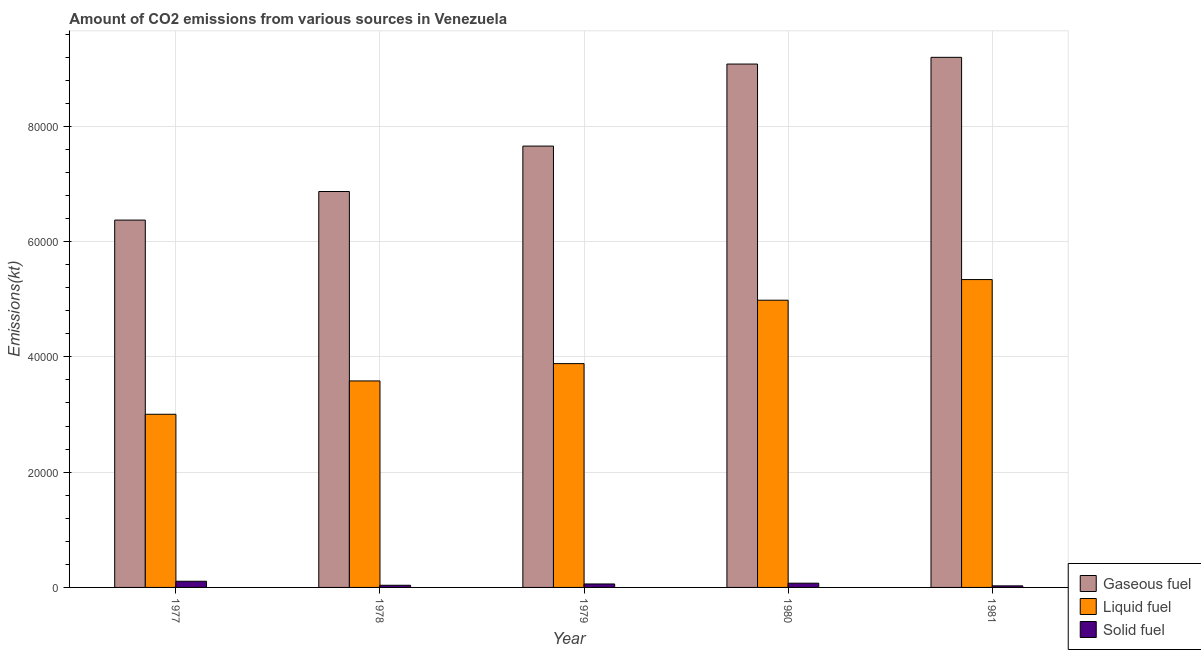Are the number of bars per tick equal to the number of legend labels?
Your answer should be very brief. Yes. How many bars are there on the 5th tick from the left?
Your answer should be very brief. 3. What is the label of the 4th group of bars from the left?
Give a very brief answer. 1980. In how many cases, is the number of bars for a given year not equal to the number of legend labels?
Your answer should be very brief. 0. What is the amount of co2 emissions from gaseous fuel in 1981?
Your answer should be very brief. 9.20e+04. Across all years, what is the maximum amount of co2 emissions from gaseous fuel?
Your answer should be compact. 9.20e+04. Across all years, what is the minimum amount of co2 emissions from solid fuel?
Keep it short and to the point. 271.36. In which year was the amount of co2 emissions from liquid fuel minimum?
Provide a succinct answer. 1977. What is the total amount of co2 emissions from liquid fuel in the graph?
Offer a very short reply. 2.08e+05. What is the difference between the amount of co2 emissions from liquid fuel in 1977 and that in 1979?
Offer a very short reply. -8789.8. What is the difference between the amount of co2 emissions from liquid fuel in 1978 and the amount of co2 emissions from solid fuel in 1981?
Offer a very short reply. -1.76e+04. What is the average amount of co2 emissions from solid fuel per year?
Your answer should be very brief. 610.19. What is the ratio of the amount of co2 emissions from solid fuel in 1980 to that in 1981?
Provide a short and direct response. 2.7. What is the difference between the highest and the second highest amount of co2 emissions from liquid fuel?
Your answer should be very brief. 3578.99. What is the difference between the highest and the lowest amount of co2 emissions from gaseous fuel?
Make the answer very short. 2.82e+04. In how many years, is the amount of co2 emissions from gaseous fuel greater than the average amount of co2 emissions from gaseous fuel taken over all years?
Your answer should be compact. 2. What does the 2nd bar from the left in 1979 represents?
Offer a terse response. Liquid fuel. What does the 2nd bar from the right in 1979 represents?
Your answer should be very brief. Liquid fuel. Is it the case that in every year, the sum of the amount of co2 emissions from gaseous fuel and amount of co2 emissions from liquid fuel is greater than the amount of co2 emissions from solid fuel?
Provide a short and direct response. Yes. What is the difference between two consecutive major ticks on the Y-axis?
Your answer should be very brief. 2.00e+04. Are the values on the major ticks of Y-axis written in scientific E-notation?
Keep it short and to the point. No. Does the graph contain any zero values?
Make the answer very short. No. Does the graph contain grids?
Keep it short and to the point. Yes. How many legend labels are there?
Offer a terse response. 3. How are the legend labels stacked?
Give a very brief answer. Vertical. What is the title of the graph?
Your answer should be compact. Amount of CO2 emissions from various sources in Venezuela. What is the label or title of the X-axis?
Your answer should be compact. Year. What is the label or title of the Y-axis?
Provide a short and direct response. Emissions(kt). What is the Emissions(kt) in Gaseous fuel in 1977?
Ensure brevity in your answer.  6.37e+04. What is the Emissions(kt) in Liquid fuel in 1977?
Provide a short and direct response. 3.00e+04. What is the Emissions(kt) of Solid fuel in 1977?
Your answer should be compact. 1070.76. What is the Emissions(kt) of Gaseous fuel in 1978?
Ensure brevity in your answer.  6.87e+04. What is the Emissions(kt) in Liquid fuel in 1978?
Keep it short and to the point. 3.58e+04. What is the Emissions(kt) of Solid fuel in 1978?
Provide a short and direct response. 374.03. What is the Emissions(kt) in Gaseous fuel in 1979?
Keep it short and to the point. 7.66e+04. What is the Emissions(kt) of Liquid fuel in 1979?
Offer a terse response. 3.88e+04. What is the Emissions(kt) in Solid fuel in 1979?
Ensure brevity in your answer.  601.39. What is the Emissions(kt) of Gaseous fuel in 1980?
Provide a short and direct response. 9.08e+04. What is the Emissions(kt) of Liquid fuel in 1980?
Offer a terse response. 4.98e+04. What is the Emissions(kt) in Solid fuel in 1980?
Make the answer very short. 733.4. What is the Emissions(kt) of Gaseous fuel in 1981?
Ensure brevity in your answer.  9.20e+04. What is the Emissions(kt) in Liquid fuel in 1981?
Provide a succinct answer. 5.34e+04. What is the Emissions(kt) in Solid fuel in 1981?
Give a very brief answer. 271.36. Across all years, what is the maximum Emissions(kt) of Gaseous fuel?
Provide a short and direct response. 9.20e+04. Across all years, what is the maximum Emissions(kt) of Liquid fuel?
Make the answer very short. 5.34e+04. Across all years, what is the maximum Emissions(kt) in Solid fuel?
Keep it short and to the point. 1070.76. Across all years, what is the minimum Emissions(kt) in Gaseous fuel?
Offer a terse response. 6.37e+04. Across all years, what is the minimum Emissions(kt) of Liquid fuel?
Your answer should be very brief. 3.00e+04. Across all years, what is the minimum Emissions(kt) in Solid fuel?
Provide a succinct answer. 271.36. What is the total Emissions(kt) in Gaseous fuel in the graph?
Keep it short and to the point. 3.92e+05. What is the total Emissions(kt) in Liquid fuel in the graph?
Your response must be concise. 2.08e+05. What is the total Emissions(kt) of Solid fuel in the graph?
Your answer should be compact. 3050.94. What is the difference between the Emissions(kt) of Gaseous fuel in 1977 and that in 1978?
Offer a very short reply. -4957.78. What is the difference between the Emissions(kt) in Liquid fuel in 1977 and that in 1978?
Offer a terse response. -5786.53. What is the difference between the Emissions(kt) of Solid fuel in 1977 and that in 1978?
Provide a short and direct response. 696.73. What is the difference between the Emissions(kt) in Gaseous fuel in 1977 and that in 1979?
Give a very brief answer. -1.28e+04. What is the difference between the Emissions(kt) in Liquid fuel in 1977 and that in 1979?
Ensure brevity in your answer.  -8789.8. What is the difference between the Emissions(kt) of Solid fuel in 1977 and that in 1979?
Your answer should be compact. 469.38. What is the difference between the Emissions(kt) in Gaseous fuel in 1977 and that in 1980?
Offer a terse response. -2.71e+04. What is the difference between the Emissions(kt) of Liquid fuel in 1977 and that in 1980?
Your response must be concise. -1.98e+04. What is the difference between the Emissions(kt) of Solid fuel in 1977 and that in 1980?
Your answer should be compact. 337.36. What is the difference between the Emissions(kt) in Gaseous fuel in 1977 and that in 1981?
Your response must be concise. -2.82e+04. What is the difference between the Emissions(kt) of Liquid fuel in 1977 and that in 1981?
Make the answer very short. -2.34e+04. What is the difference between the Emissions(kt) of Solid fuel in 1977 and that in 1981?
Provide a succinct answer. 799.41. What is the difference between the Emissions(kt) of Gaseous fuel in 1978 and that in 1979?
Give a very brief answer. -7880.38. What is the difference between the Emissions(kt) in Liquid fuel in 1978 and that in 1979?
Your answer should be compact. -3003.27. What is the difference between the Emissions(kt) of Solid fuel in 1978 and that in 1979?
Ensure brevity in your answer.  -227.35. What is the difference between the Emissions(kt) of Gaseous fuel in 1978 and that in 1980?
Offer a terse response. -2.21e+04. What is the difference between the Emissions(kt) of Liquid fuel in 1978 and that in 1980?
Ensure brevity in your answer.  -1.40e+04. What is the difference between the Emissions(kt) in Solid fuel in 1978 and that in 1980?
Keep it short and to the point. -359.37. What is the difference between the Emissions(kt) of Gaseous fuel in 1978 and that in 1981?
Make the answer very short. -2.33e+04. What is the difference between the Emissions(kt) in Liquid fuel in 1978 and that in 1981?
Give a very brief answer. -1.76e+04. What is the difference between the Emissions(kt) of Solid fuel in 1978 and that in 1981?
Give a very brief answer. 102.68. What is the difference between the Emissions(kt) of Gaseous fuel in 1979 and that in 1980?
Your response must be concise. -1.42e+04. What is the difference between the Emissions(kt) in Liquid fuel in 1979 and that in 1980?
Your response must be concise. -1.10e+04. What is the difference between the Emissions(kt) of Solid fuel in 1979 and that in 1980?
Your answer should be compact. -132.01. What is the difference between the Emissions(kt) in Gaseous fuel in 1979 and that in 1981?
Give a very brief answer. -1.54e+04. What is the difference between the Emissions(kt) of Liquid fuel in 1979 and that in 1981?
Provide a succinct answer. -1.46e+04. What is the difference between the Emissions(kt) in Solid fuel in 1979 and that in 1981?
Offer a terse response. 330.03. What is the difference between the Emissions(kt) of Gaseous fuel in 1980 and that in 1981?
Provide a short and direct response. -1166.11. What is the difference between the Emissions(kt) in Liquid fuel in 1980 and that in 1981?
Ensure brevity in your answer.  -3578.99. What is the difference between the Emissions(kt) of Solid fuel in 1980 and that in 1981?
Keep it short and to the point. 462.04. What is the difference between the Emissions(kt) in Gaseous fuel in 1977 and the Emissions(kt) in Liquid fuel in 1978?
Your answer should be compact. 2.79e+04. What is the difference between the Emissions(kt) of Gaseous fuel in 1977 and the Emissions(kt) of Solid fuel in 1978?
Offer a very short reply. 6.34e+04. What is the difference between the Emissions(kt) of Liquid fuel in 1977 and the Emissions(kt) of Solid fuel in 1978?
Give a very brief answer. 2.97e+04. What is the difference between the Emissions(kt) of Gaseous fuel in 1977 and the Emissions(kt) of Liquid fuel in 1979?
Provide a succinct answer. 2.49e+04. What is the difference between the Emissions(kt) of Gaseous fuel in 1977 and the Emissions(kt) of Solid fuel in 1979?
Offer a terse response. 6.31e+04. What is the difference between the Emissions(kt) of Liquid fuel in 1977 and the Emissions(kt) of Solid fuel in 1979?
Make the answer very short. 2.94e+04. What is the difference between the Emissions(kt) in Gaseous fuel in 1977 and the Emissions(kt) in Liquid fuel in 1980?
Your response must be concise. 1.39e+04. What is the difference between the Emissions(kt) of Gaseous fuel in 1977 and the Emissions(kt) of Solid fuel in 1980?
Offer a terse response. 6.30e+04. What is the difference between the Emissions(kt) in Liquid fuel in 1977 and the Emissions(kt) in Solid fuel in 1980?
Make the answer very short. 2.93e+04. What is the difference between the Emissions(kt) of Gaseous fuel in 1977 and the Emissions(kt) of Liquid fuel in 1981?
Provide a succinct answer. 1.03e+04. What is the difference between the Emissions(kt) in Gaseous fuel in 1977 and the Emissions(kt) in Solid fuel in 1981?
Provide a succinct answer. 6.35e+04. What is the difference between the Emissions(kt) in Liquid fuel in 1977 and the Emissions(kt) in Solid fuel in 1981?
Your answer should be compact. 2.98e+04. What is the difference between the Emissions(kt) of Gaseous fuel in 1978 and the Emissions(kt) of Liquid fuel in 1979?
Provide a succinct answer. 2.99e+04. What is the difference between the Emissions(kt) in Gaseous fuel in 1978 and the Emissions(kt) in Solid fuel in 1979?
Provide a succinct answer. 6.81e+04. What is the difference between the Emissions(kt) of Liquid fuel in 1978 and the Emissions(kt) of Solid fuel in 1979?
Keep it short and to the point. 3.52e+04. What is the difference between the Emissions(kt) in Gaseous fuel in 1978 and the Emissions(kt) in Liquid fuel in 1980?
Provide a short and direct response. 1.89e+04. What is the difference between the Emissions(kt) of Gaseous fuel in 1978 and the Emissions(kt) of Solid fuel in 1980?
Ensure brevity in your answer.  6.80e+04. What is the difference between the Emissions(kt) of Liquid fuel in 1978 and the Emissions(kt) of Solid fuel in 1980?
Give a very brief answer. 3.51e+04. What is the difference between the Emissions(kt) of Gaseous fuel in 1978 and the Emissions(kt) of Liquid fuel in 1981?
Your answer should be very brief. 1.53e+04. What is the difference between the Emissions(kt) in Gaseous fuel in 1978 and the Emissions(kt) in Solid fuel in 1981?
Offer a very short reply. 6.84e+04. What is the difference between the Emissions(kt) in Liquid fuel in 1978 and the Emissions(kt) in Solid fuel in 1981?
Make the answer very short. 3.56e+04. What is the difference between the Emissions(kt) of Gaseous fuel in 1979 and the Emissions(kt) of Liquid fuel in 1980?
Ensure brevity in your answer.  2.67e+04. What is the difference between the Emissions(kt) in Gaseous fuel in 1979 and the Emissions(kt) in Solid fuel in 1980?
Ensure brevity in your answer.  7.58e+04. What is the difference between the Emissions(kt) of Liquid fuel in 1979 and the Emissions(kt) of Solid fuel in 1980?
Keep it short and to the point. 3.81e+04. What is the difference between the Emissions(kt) of Gaseous fuel in 1979 and the Emissions(kt) of Liquid fuel in 1981?
Your response must be concise. 2.32e+04. What is the difference between the Emissions(kt) in Gaseous fuel in 1979 and the Emissions(kt) in Solid fuel in 1981?
Offer a very short reply. 7.63e+04. What is the difference between the Emissions(kt) in Liquid fuel in 1979 and the Emissions(kt) in Solid fuel in 1981?
Ensure brevity in your answer.  3.86e+04. What is the difference between the Emissions(kt) in Gaseous fuel in 1980 and the Emissions(kt) in Liquid fuel in 1981?
Give a very brief answer. 3.74e+04. What is the difference between the Emissions(kt) of Gaseous fuel in 1980 and the Emissions(kt) of Solid fuel in 1981?
Ensure brevity in your answer.  9.05e+04. What is the difference between the Emissions(kt) in Liquid fuel in 1980 and the Emissions(kt) in Solid fuel in 1981?
Offer a terse response. 4.96e+04. What is the average Emissions(kt) in Gaseous fuel per year?
Your answer should be very brief. 7.84e+04. What is the average Emissions(kt) of Liquid fuel per year?
Your response must be concise. 4.16e+04. What is the average Emissions(kt) of Solid fuel per year?
Keep it short and to the point. 610.19. In the year 1977, what is the difference between the Emissions(kt) in Gaseous fuel and Emissions(kt) in Liquid fuel?
Provide a short and direct response. 3.37e+04. In the year 1977, what is the difference between the Emissions(kt) of Gaseous fuel and Emissions(kt) of Solid fuel?
Provide a succinct answer. 6.27e+04. In the year 1977, what is the difference between the Emissions(kt) in Liquid fuel and Emissions(kt) in Solid fuel?
Provide a succinct answer. 2.90e+04. In the year 1978, what is the difference between the Emissions(kt) of Gaseous fuel and Emissions(kt) of Liquid fuel?
Provide a short and direct response. 3.29e+04. In the year 1978, what is the difference between the Emissions(kt) of Gaseous fuel and Emissions(kt) of Solid fuel?
Ensure brevity in your answer.  6.83e+04. In the year 1978, what is the difference between the Emissions(kt) in Liquid fuel and Emissions(kt) in Solid fuel?
Your response must be concise. 3.55e+04. In the year 1979, what is the difference between the Emissions(kt) of Gaseous fuel and Emissions(kt) of Liquid fuel?
Give a very brief answer. 3.77e+04. In the year 1979, what is the difference between the Emissions(kt) of Gaseous fuel and Emissions(kt) of Solid fuel?
Ensure brevity in your answer.  7.60e+04. In the year 1979, what is the difference between the Emissions(kt) in Liquid fuel and Emissions(kt) in Solid fuel?
Keep it short and to the point. 3.82e+04. In the year 1980, what is the difference between the Emissions(kt) of Gaseous fuel and Emissions(kt) of Liquid fuel?
Your answer should be very brief. 4.10e+04. In the year 1980, what is the difference between the Emissions(kt) in Gaseous fuel and Emissions(kt) in Solid fuel?
Provide a succinct answer. 9.01e+04. In the year 1980, what is the difference between the Emissions(kt) of Liquid fuel and Emissions(kt) of Solid fuel?
Your response must be concise. 4.91e+04. In the year 1981, what is the difference between the Emissions(kt) of Gaseous fuel and Emissions(kt) of Liquid fuel?
Your response must be concise. 3.86e+04. In the year 1981, what is the difference between the Emissions(kt) in Gaseous fuel and Emissions(kt) in Solid fuel?
Offer a very short reply. 9.17e+04. In the year 1981, what is the difference between the Emissions(kt) in Liquid fuel and Emissions(kt) in Solid fuel?
Ensure brevity in your answer.  5.31e+04. What is the ratio of the Emissions(kt) in Gaseous fuel in 1977 to that in 1978?
Ensure brevity in your answer.  0.93. What is the ratio of the Emissions(kt) in Liquid fuel in 1977 to that in 1978?
Your answer should be compact. 0.84. What is the ratio of the Emissions(kt) of Solid fuel in 1977 to that in 1978?
Your response must be concise. 2.86. What is the ratio of the Emissions(kt) in Gaseous fuel in 1977 to that in 1979?
Your response must be concise. 0.83. What is the ratio of the Emissions(kt) of Liquid fuel in 1977 to that in 1979?
Give a very brief answer. 0.77. What is the ratio of the Emissions(kt) of Solid fuel in 1977 to that in 1979?
Ensure brevity in your answer.  1.78. What is the ratio of the Emissions(kt) of Gaseous fuel in 1977 to that in 1980?
Your answer should be very brief. 0.7. What is the ratio of the Emissions(kt) in Liquid fuel in 1977 to that in 1980?
Give a very brief answer. 0.6. What is the ratio of the Emissions(kt) of Solid fuel in 1977 to that in 1980?
Offer a terse response. 1.46. What is the ratio of the Emissions(kt) in Gaseous fuel in 1977 to that in 1981?
Your response must be concise. 0.69. What is the ratio of the Emissions(kt) of Liquid fuel in 1977 to that in 1981?
Provide a short and direct response. 0.56. What is the ratio of the Emissions(kt) of Solid fuel in 1977 to that in 1981?
Offer a terse response. 3.95. What is the ratio of the Emissions(kt) of Gaseous fuel in 1978 to that in 1979?
Your response must be concise. 0.9. What is the ratio of the Emissions(kt) in Liquid fuel in 1978 to that in 1979?
Your answer should be compact. 0.92. What is the ratio of the Emissions(kt) in Solid fuel in 1978 to that in 1979?
Make the answer very short. 0.62. What is the ratio of the Emissions(kt) of Gaseous fuel in 1978 to that in 1980?
Your response must be concise. 0.76. What is the ratio of the Emissions(kt) in Liquid fuel in 1978 to that in 1980?
Your response must be concise. 0.72. What is the ratio of the Emissions(kt) of Solid fuel in 1978 to that in 1980?
Keep it short and to the point. 0.51. What is the ratio of the Emissions(kt) in Gaseous fuel in 1978 to that in 1981?
Give a very brief answer. 0.75. What is the ratio of the Emissions(kt) in Liquid fuel in 1978 to that in 1981?
Ensure brevity in your answer.  0.67. What is the ratio of the Emissions(kt) of Solid fuel in 1978 to that in 1981?
Your answer should be very brief. 1.38. What is the ratio of the Emissions(kt) in Gaseous fuel in 1979 to that in 1980?
Your answer should be compact. 0.84. What is the ratio of the Emissions(kt) in Liquid fuel in 1979 to that in 1980?
Offer a very short reply. 0.78. What is the ratio of the Emissions(kt) in Solid fuel in 1979 to that in 1980?
Your answer should be very brief. 0.82. What is the ratio of the Emissions(kt) in Gaseous fuel in 1979 to that in 1981?
Offer a very short reply. 0.83. What is the ratio of the Emissions(kt) of Liquid fuel in 1979 to that in 1981?
Give a very brief answer. 0.73. What is the ratio of the Emissions(kt) in Solid fuel in 1979 to that in 1981?
Provide a short and direct response. 2.22. What is the ratio of the Emissions(kt) in Gaseous fuel in 1980 to that in 1981?
Your answer should be very brief. 0.99. What is the ratio of the Emissions(kt) in Liquid fuel in 1980 to that in 1981?
Your answer should be compact. 0.93. What is the ratio of the Emissions(kt) in Solid fuel in 1980 to that in 1981?
Your answer should be very brief. 2.7. What is the difference between the highest and the second highest Emissions(kt) in Gaseous fuel?
Your answer should be very brief. 1166.11. What is the difference between the highest and the second highest Emissions(kt) of Liquid fuel?
Offer a terse response. 3578.99. What is the difference between the highest and the second highest Emissions(kt) of Solid fuel?
Ensure brevity in your answer.  337.36. What is the difference between the highest and the lowest Emissions(kt) of Gaseous fuel?
Your response must be concise. 2.82e+04. What is the difference between the highest and the lowest Emissions(kt) of Liquid fuel?
Offer a terse response. 2.34e+04. What is the difference between the highest and the lowest Emissions(kt) of Solid fuel?
Ensure brevity in your answer.  799.41. 